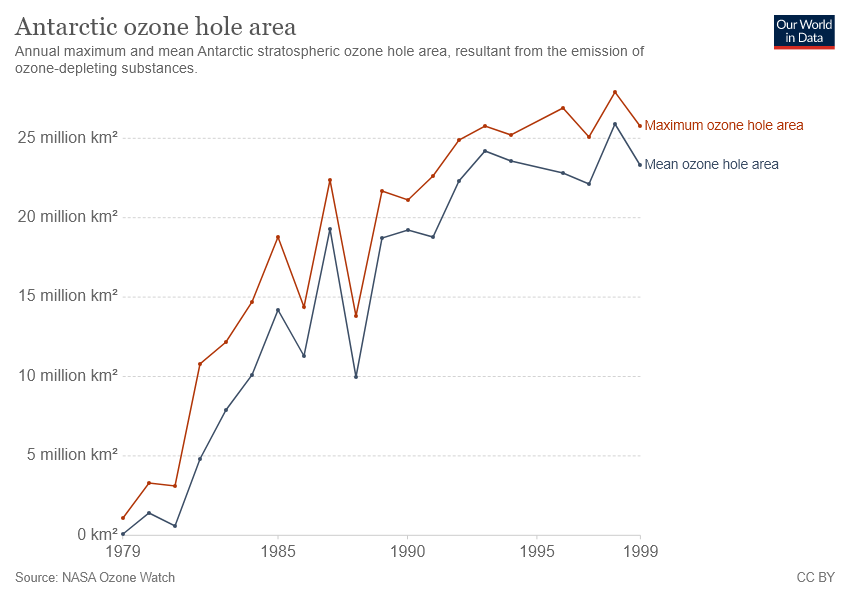Highlight a few significant elements in this photo. The red color line represents the maximum ozone hole area. The maximum area of the ozone hole occurred between [1995 and 1999]. 